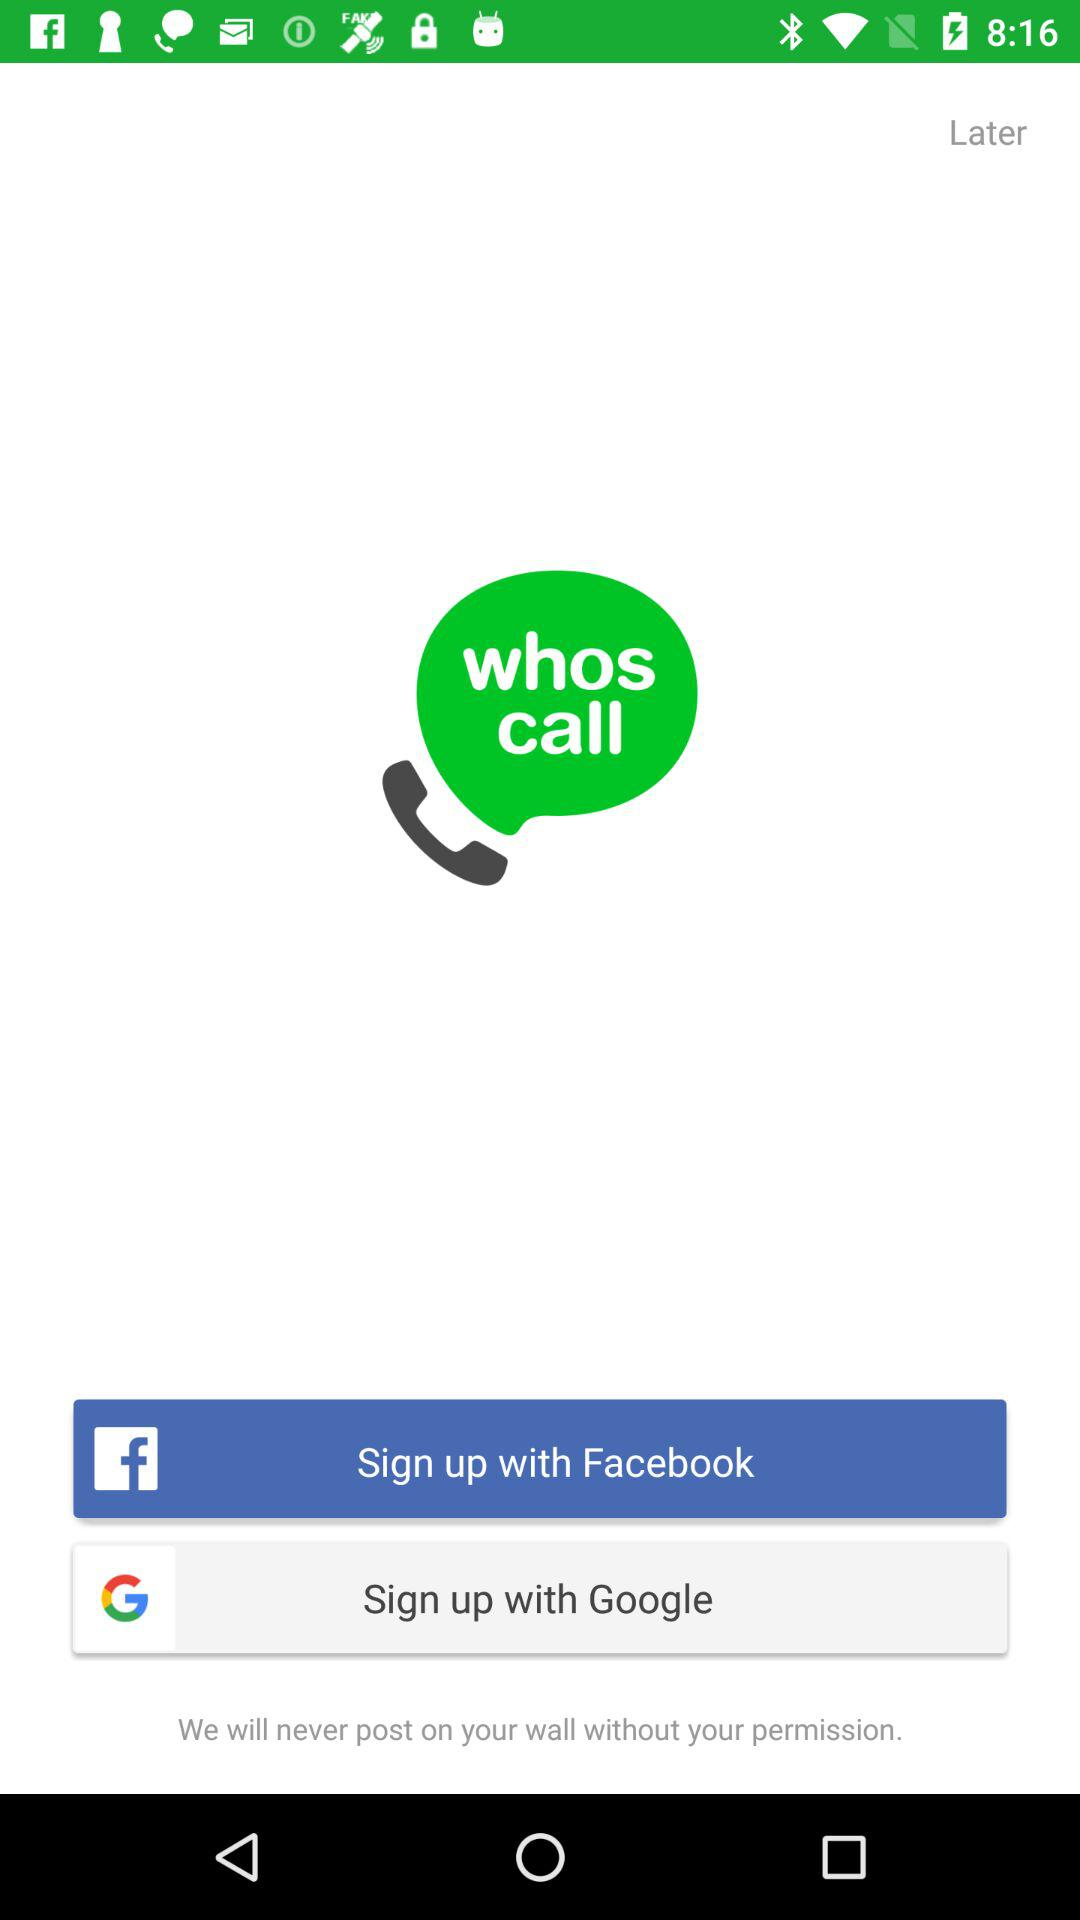Which account can be used to sign up? The accounts that can be used to sign up are "Facebook" and "Google". 